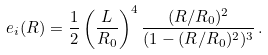Convert formula to latex. <formula><loc_0><loc_0><loc_500><loc_500>e _ { i } ( { R } ) = \frac { 1 } { 2 } \left ( \frac { L } { R _ { 0 } } \right ) ^ { 4 } \frac { ( R / R _ { 0 } ) ^ { 2 } } { ( 1 - ( R / R _ { 0 } ) ^ { 2 } ) ^ { 3 } } \, .</formula> 